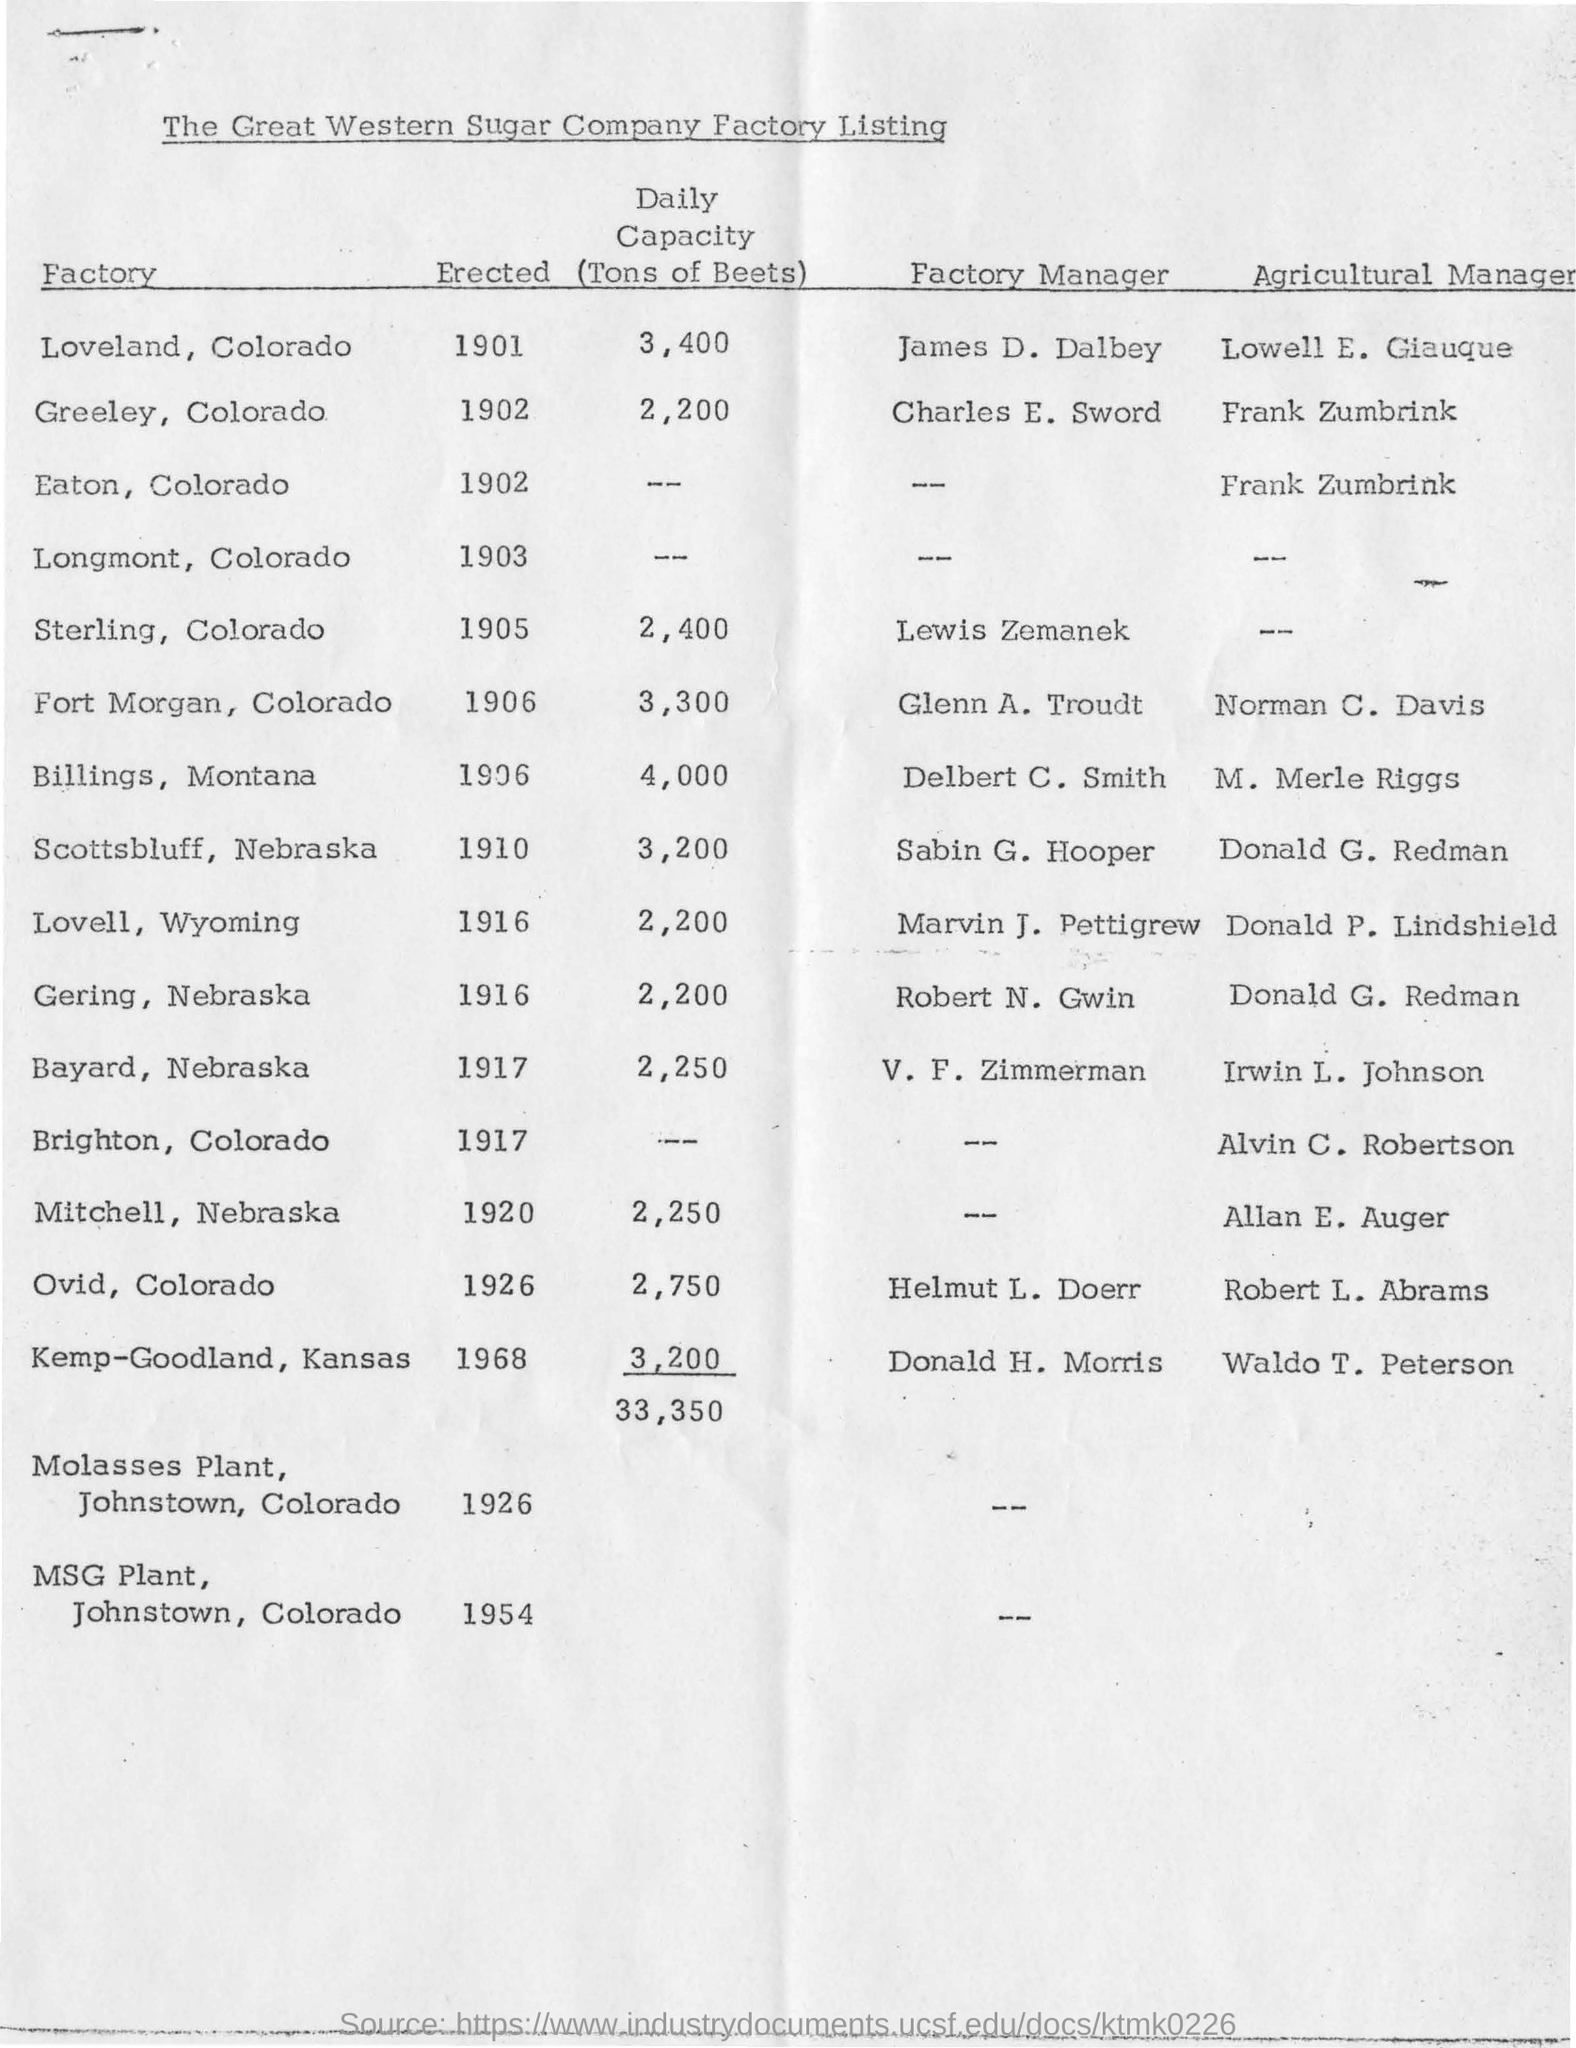Point out several critical features in this image. The daily capacity of the Loveland, Colorado factory is 3,400 units. The factory manager of Loveland, Colorado is James D. Dalbey. On January 1, 1901, the Loveland, Colorado factory was established. 